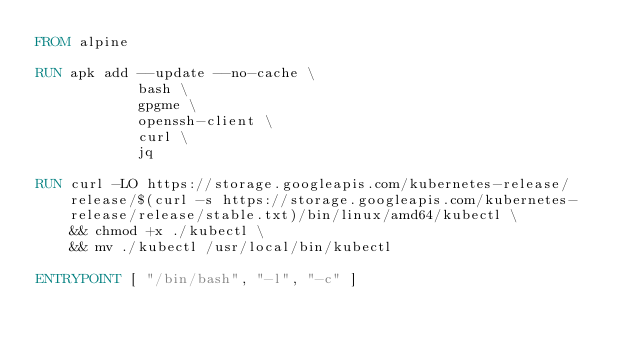<code> <loc_0><loc_0><loc_500><loc_500><_Dockerfile_>FROM alpine

RUN apk add --update --no-cache \
            bash \
            gpgme \
            openssh-client \
            curl \
            jq 

RUN curl -LO https://storage.googleapis.com/kubernetes-release/release/$(curl -s https://storage.googleapis.com/kubernetes-release/release/stable.txt)/bin/linux/amd64/kubectl \
    && chmod +x ./kubectl \
    && mv ./kubectl /usr/local/bin/kubectl

ENTRYPOINT [ "/bin/bash", "-l", "-c" ]</code> 